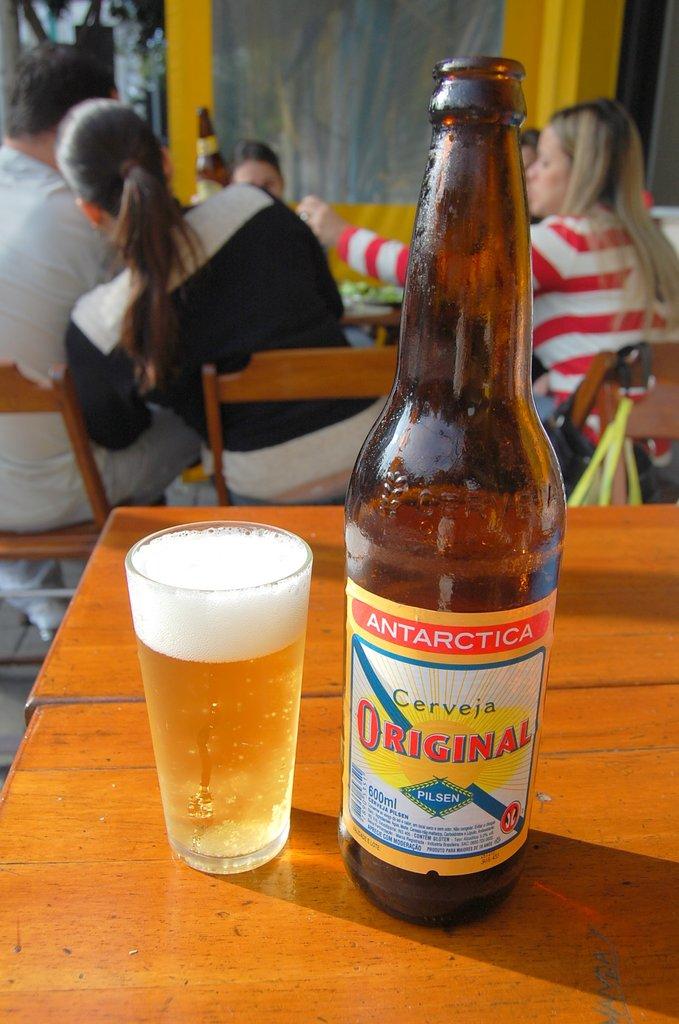What continent is the beer named for?
Your answer should be compact. Antarctica. What is the name of the beer?
Make the answer very short. Antarctica. 